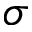Convert formula to latex. <formula><loc_0><loc_0><loc_500><loc_500>\sigma</formula> 